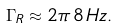Convert formula to latex. <formula><loc_0><loc_0><loc_500><loc_500>\Gamma _ { R } \approx 2 \pi \, 8 \, H z .</formula> 